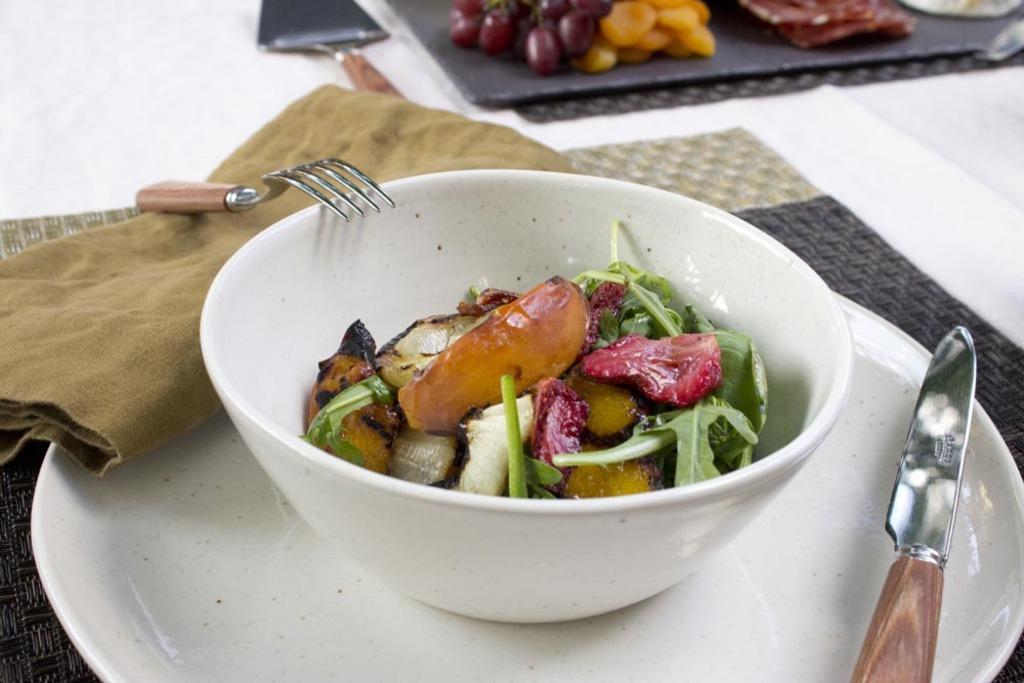Could you give a brief overview of what you see in this image? In this image, we can see a table, on the table, we can see a white colored cloth. In the middle of the table, we can see a mat and a plate. On the plate, we can see a knife and a bowl with some food. On the left side of the table, we can see a cloth and a fork. In the background, we can see some fruits and a spoon. 